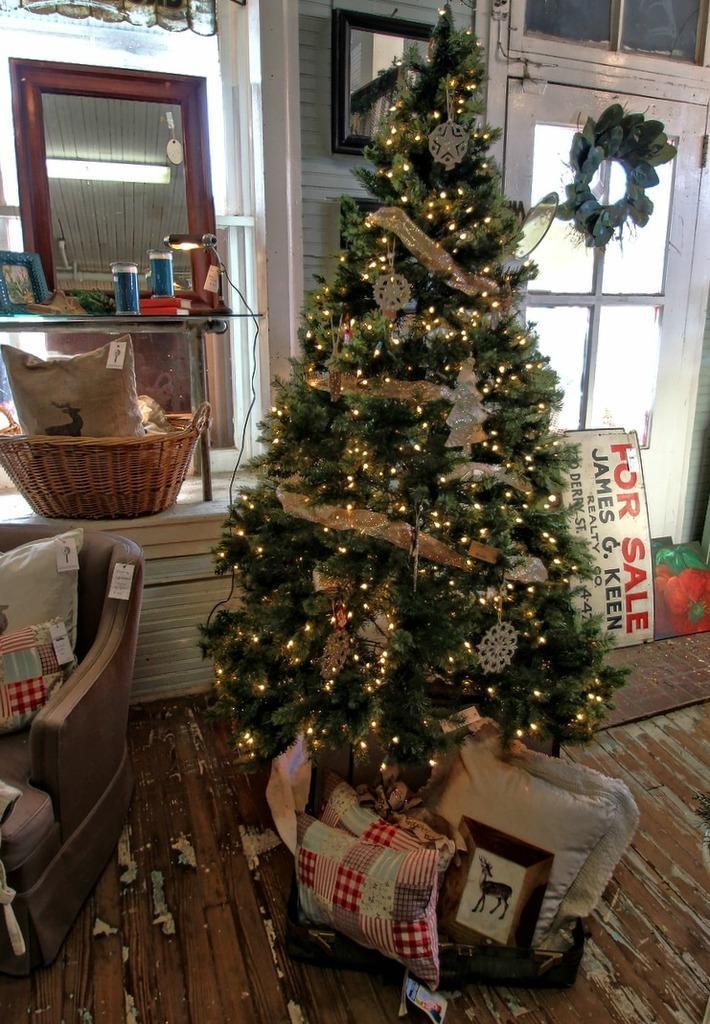In one or two sentences, can you explain what this image depicts? In this picture there is a Christmas tree decorated with some lights. Under the tree there are some pillows and bag here. Beside the tree there is a sofa and a basket on the desk. In the background there is a mirror and a door here. 